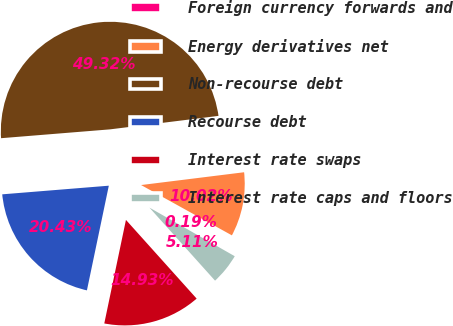Convert chart to OTSL. <chart><loc_0><loc_0><loc_500><loc_500><pie_chart><fcel>Foreign currency forwards and<fcel>Energy derivatives net<fcel>Non-recourse debt<fcel>Recourse debt<fcel>Interest rate swaps<fcel>Interest rate caps and floors<nl><fcel>0.19%<fcel>10.02%<fcel>49.32%<fcel>20.43%<fcel>14.93%<fcel>5.11%<nl></chart> 